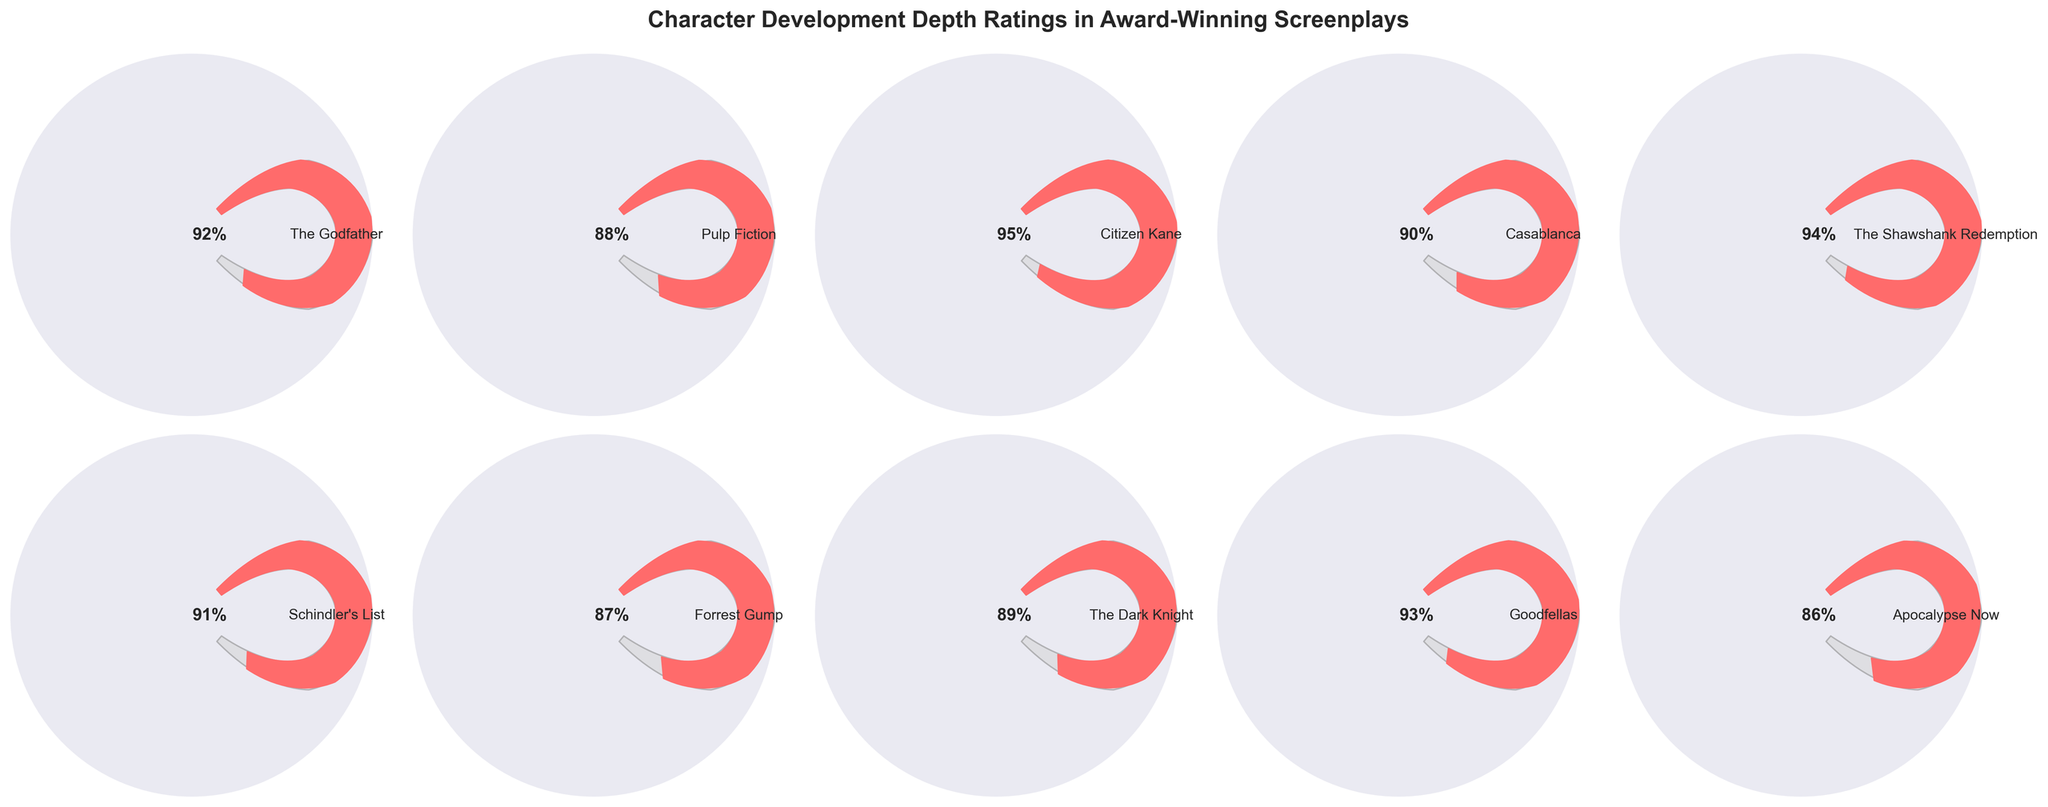Which screenplay has the highest character development depth rating? By observing the gauges, the screenplay with the highest value is the one with the largest portion of the arc filled in. "Citizen Kane" has the gauge almost fully filled at 95%.
Answer: Citizen Kane What is the character development depth rating for "The Shawshank Redemption"? By checking "The Shawshank Redemption" gauge, it is filled up to the 94% mark.
Answer: 94% Which screenplay has the lowest character development depth rating? The smallest filled arc corresponds to the lowest value. "Apocalypse Now" has the lowest rating at 86%.
Answer: Apocalypse Now How many screenplays have a development depth rating of 90% or above? By counting the gauges that show 90% or higher, we see "The Godfather" (92%), "Citizen Kane" (95%), "Casablanca" (90%), "The Shawshank Redemption" (94%), "Schindler's List" (91%), and "Goodfellas" (93%). Thus, there are 6 screenplays.
Answer: 6 What is the average character development depth rating among all the screenplays? Sum the ratings of all screenplays: 92 + 88 + 95 + 90 + 94 + 91 + 87 + 89 + 93 + 86 = 905. Divide by the number of screenplays (10): 905 / 10 = 90.5.
Answer: 90.5 How much higher is "The Dark Knight"'s development depth rating compared to "Apocalypse Now"? Subtract the rating of "Apocalypse Now" from "The Dark Knight": 89 - 86 = 3.
Answer: 3 Which screenplays have a development depth rating between 85% and 90%? Gauges between 85% and 90% are "Pulp Fiction" (88%), "Casablanca" (90%), "Forrest Gump" (87%), "The Dark Knight" (89%), and "Apocalypse Now" (86%).
Answer: Pulp Fiction, Casablanca, Forrest Gump, The Dark Knight, Apocalypse Now Is the character development depth rating of "Forrest Gump" higher than that of "Pulp Fiction"? Compare the ratings of "Forrest Gump" (87%) and "Pulp Fiction" (88%). "Forrest Gump" has a lower rating than "Pulp Fiction".
Answer: No What is the total sum of character development depth ratings for "The Godfather" and "Goodfellas"? Add the ratings of "The Godfather" (92%) and "Goodfellas" (93%): 92 + 93 = 185.
Answer: 185 